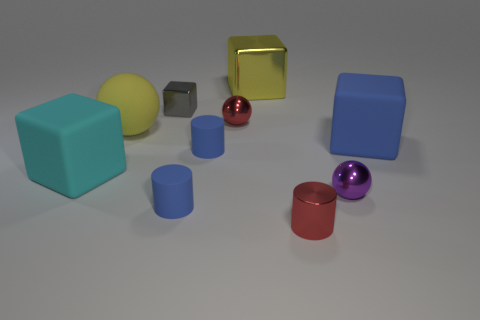There is a large yellow thing behind the small red ball; is it the same shape as the gray metal thing?
Ensure brevity in your answer.  Yes. The shiny ball behind the small ball in front of the blue block is what color?
Ensure brevity in your answer.  Red. Are there fewer red things than green shiny cylinders?
Your response must be concise. No. Is there a large block that has the same material as the red cylinder?
Your answer should be very brief. Yes. Does the large cyan matte thing have the same shape as the red thing that is behind the purple thing?
Your answer should be compact. No. There is a small gray block; are there any metal spheres behind it?
Offer a terse response. No. How many gray shiny things are the same shape as the large yellow matte thing?
Your response must be concise. 0. Is the big blue object made of the same material as the small red thing in front of the cyan rubber block?
Offer a terse response. No. How many objects are there?
Give a very brief answer. 10. What is the size of the red object that is right of the yellow cube?
Your answer should be very brief. Small. 